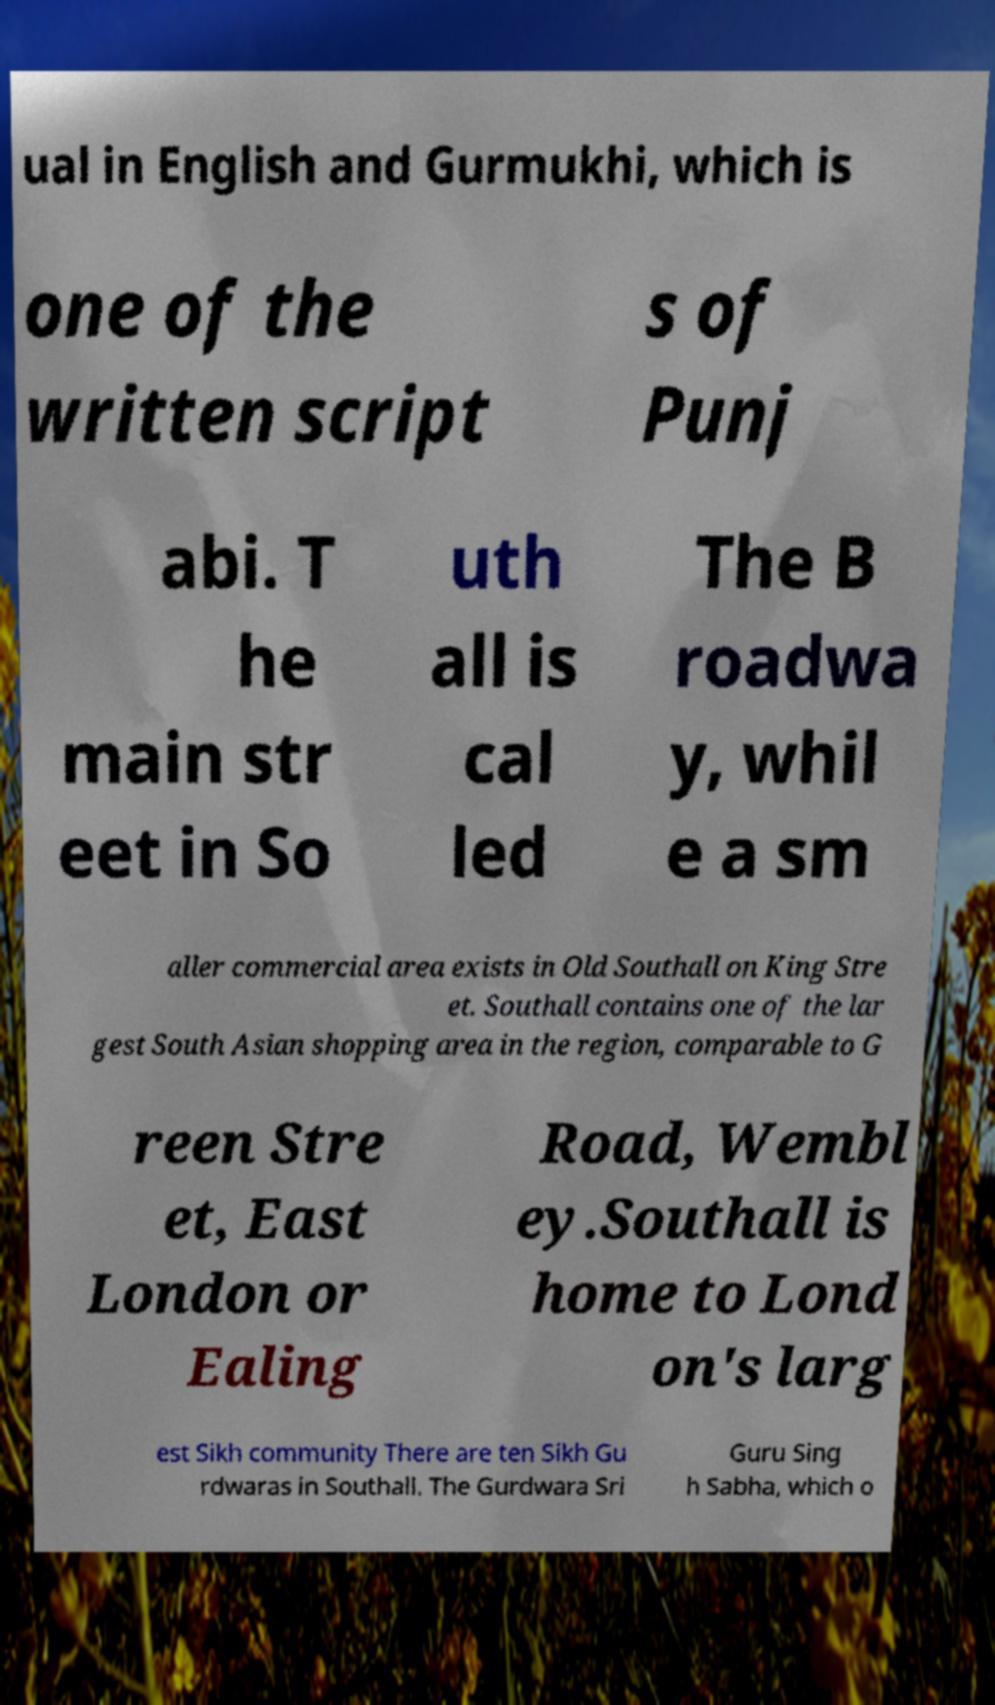Could you extract and type out the text from this image? ual in English and Gurmukhi, which is one of the written script s of Punj abi. T he main str eet in So uth all is cal led The B roadwa y, whil e a sm aller commercial area exists in Old Southall on King Stre et. Southall contains one of the lar gest South Asian shopping area in the region, comparable to G reen Stre et, East London or Ealing Road, Wembl ey.Southall is home to Lond on's larg est Sikh community There are ten Sikh Gu rdwaras in Southall. The Gurdwara Sri Guru Sing h Sabha, which o 